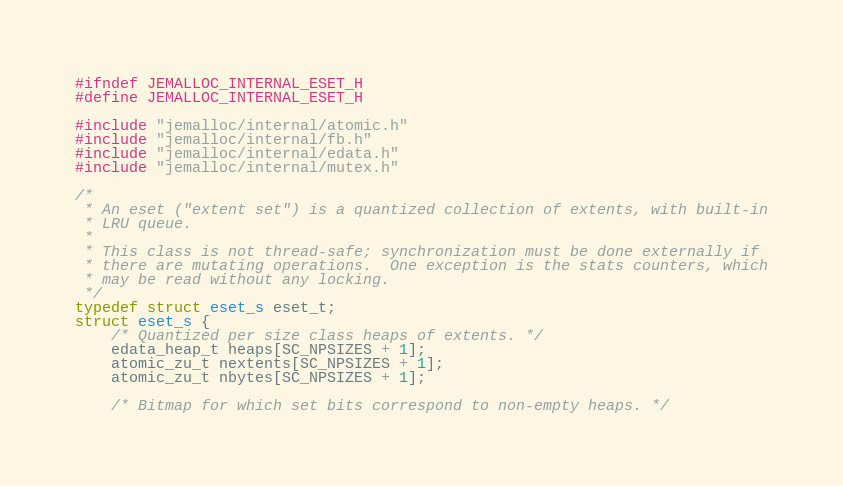Convert code to text. <code><loc_0><loc_0><loc_500><loc_500><_C_>#ifndef JEMALLOC_INTERNAL_ESET_H
#define JEMALLOC_INTERNAL_ESET_H

#include "jemalloc/internal/atomic.h"
#include "jemalloc/internal/fb.h"
#include "jemalloc/internal/edata.h"
#include "jemalloc/internal/mutex.h"

/*
 * An eset ("extent set") is a quantized collection of extents, with built-in
 * LRU queue.
 *
 * This class is not thread-safe; synchronization must be done externally if
 * there are mutating operations.  One exception is the stats counters, which
 * may be read without any locking.
 */
typedef struct eset_s eset_t;
struct eset_s {
	/* Quantized per size class heaps of extents. */
	edata_heap_t heaps[SC_NPSIZES + 1];
	atomic_zu_t nextents[SC_NPSIZES + 1];
	atomic_zu_t nbytes[SC_NPSIZES + 1];

	/* Bitmap for which set bits correspond to non-empty heaps. */</code> 